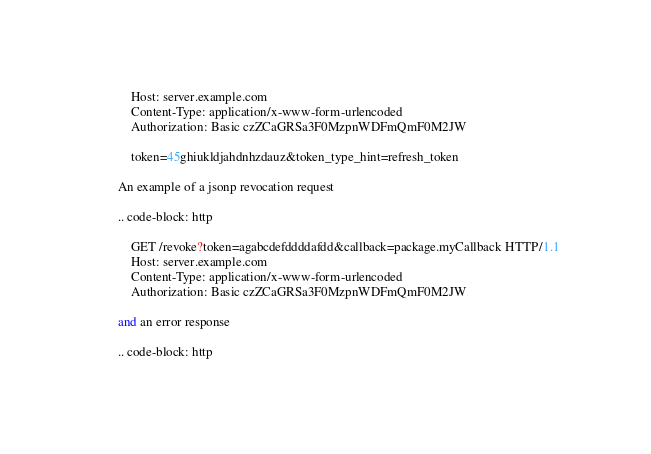<code> <loc_0><loc_0><loc_500><loc_500><_Python_>            Host: server.example.com
            Content-Type: application/x-www-form-urlencoded
            Authorization: Basic czZCaGRSa3F0MzpnWDFmQmF0M2JW

            token=45ghiukldjahdnhzdauz&token_type_hint=refresh_token

        An example of a jsonp revocation request

        .. code-block: http

            GET /revoke?token=agabcdefddddafdd&callback=package.myCallback HTTP/1.1
            Host: server.example.com
            Content-Type: application/x-www-form-urlencoded
            Authorization: Basic czZCaGRSa3F0MzpnWDFmQmF0M2JW

        and an error response

        .. code-block: http
</code> 